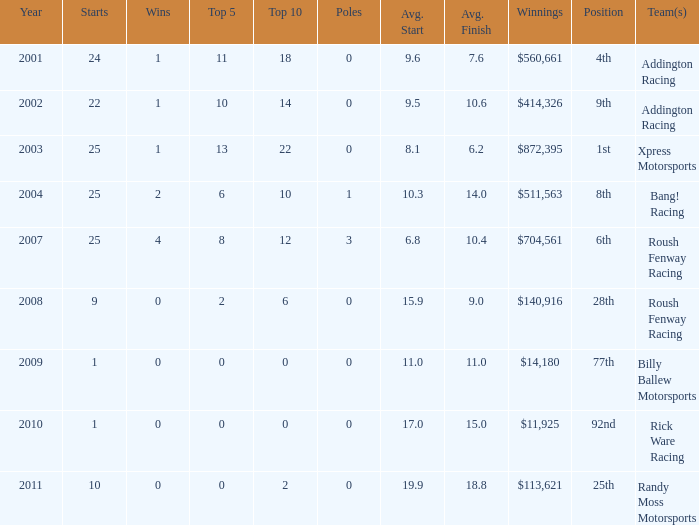How many triumphs in the 4th position? 1.0. 